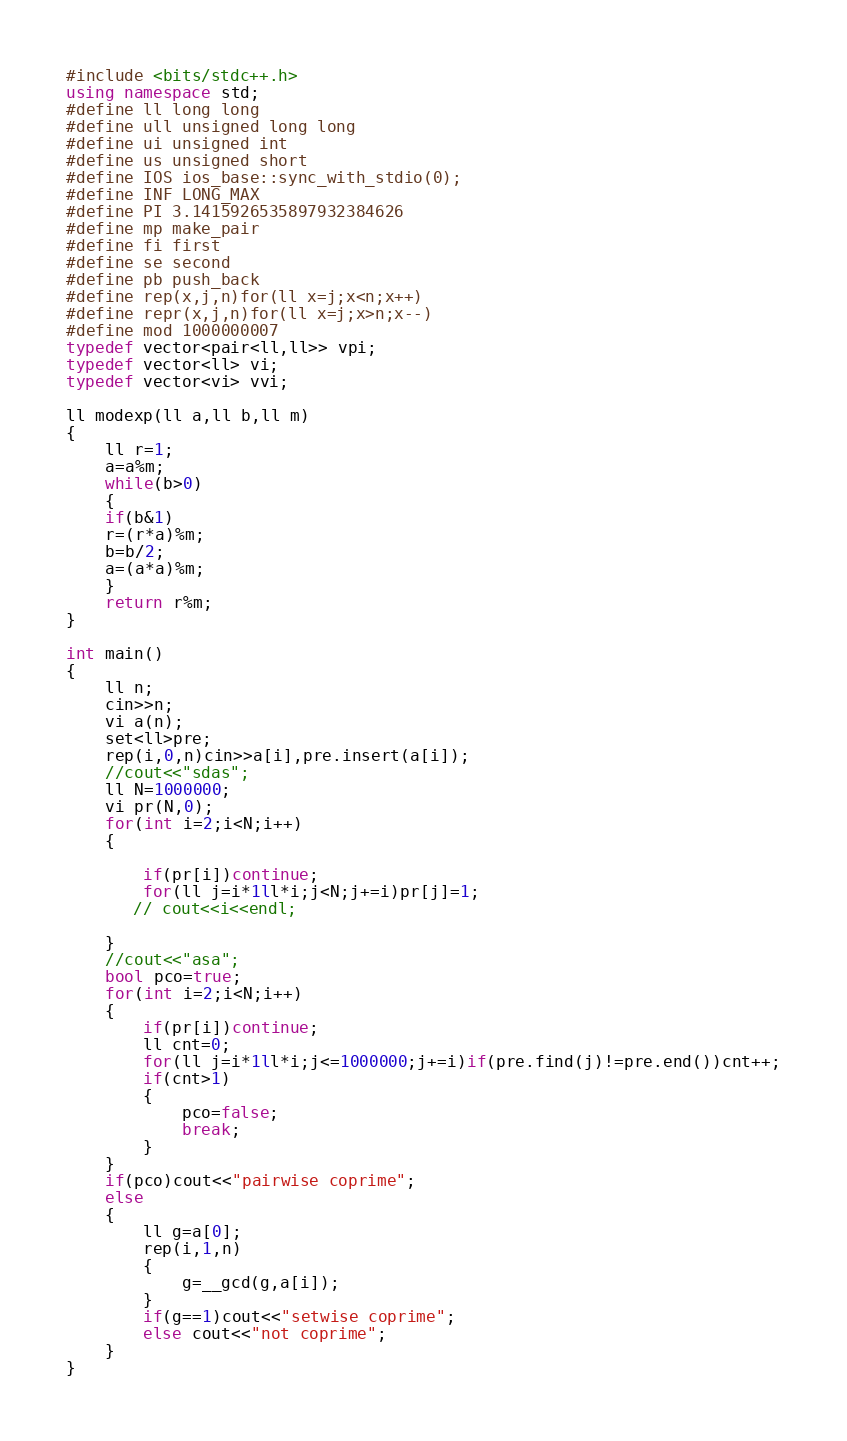Convert code to text. <code><loc_0><loc_0><loc_500><loc_500><_C++_>#include <bits/stdc++.h>
using namespace std;
#define ll long long
#define ull unsigned long long
#define ui unsigned int
#define us unsigned short
#define IOS ios_base::sync_with_stdio(0);
#define INF LONG_MAX
#define PI 3.1415926535897932384626
#define mp make_pair
#define fi first
#define se second
#define pb push_back
#define rep(x,j,n)for(ll x=j;x<n;x++)
#define repr(x,j,n)for(ll x=j;x>n;x--)
#define mod 1000000007
typedef vector<pair<ll,ll>> vpi;
typedef vector<ll> vi;
typedef vector<vi> vvi;

ll modexp(ll a,ll b,ll m)
{
    ll r=1;
    a=a%m;
    while(b>0)
    {
    if(b&1)
    r=(r*a)%m;
    b=b/2;
    a=(a*a)%m;
    }
    return r%m;
}

int main()
{
    ll n;
    cin>>n;
    vi a(n);
    set<ll>pre;
    rep(i,0,n)cin>>a[i],pre.insert(a[i]);
    //cout<<"sdas";
    ll N=1000000;
    vi pr(N,0);
    for(int i=2;i<N;i++)
    {

        if(pr[i])continue;
        for(ll j=i*1ll*i;j<N;j+=i)pr[j]=1;
       // cout<<i<<endl;

    }
    //cout<<"asa";
    bool pco=true;
    for(int i=2;i<N;i++)
    {
        if(pr[i])continue;
        ll cnt=0;
        for(ll j=i*1ll*i;j<=1000000;j+=i)if(pre.find(j)!=pre.end())cnt++;
        if(cnt>1)
        {
            pco=false;
            break;
        }
    }
    if(pco)cout<<"pairwise coprime";
    else
    {
        ll g=a[0];
        rep(i,1,n)
        {
            g=__gcd(g,a[i]);
        }
        if(g==1)cout<<"setwise coprime";
        else cout<<"not coprime";
    }
}
</code> 